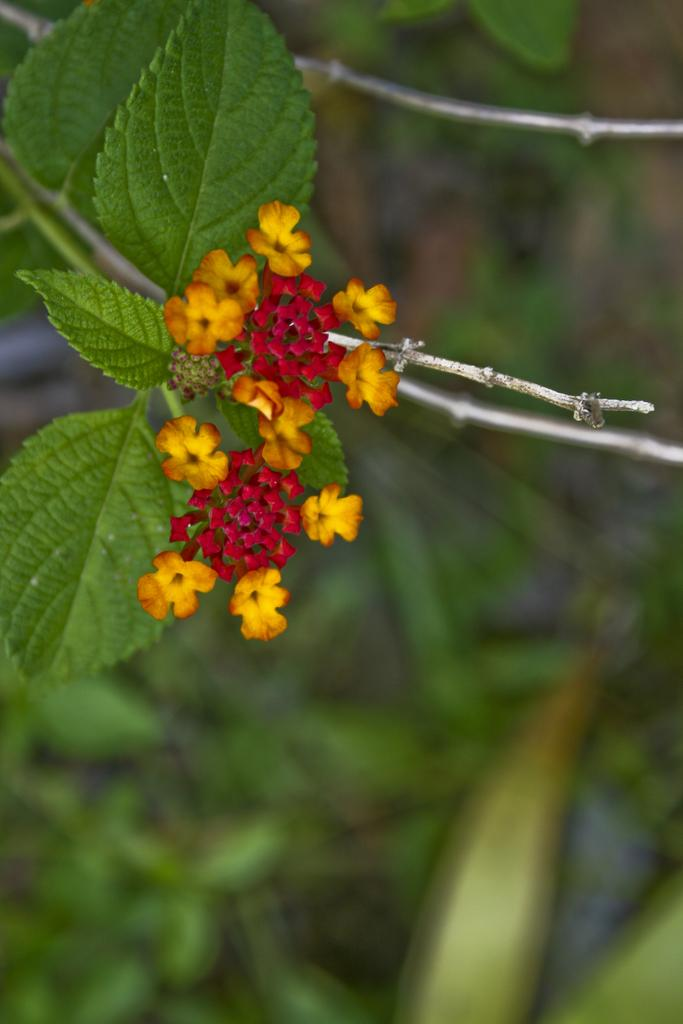What type of flora can be seen in the image? There are flowers in the image. What colors are the flowers? The flowers are red, yellow, and orange in color. Where are the flowers located? The flowers are on a plant. What color is the plant? The plant is green in color. Can you describe the background of the image? The background of the image is blurry. What else can be seen in the background? There are plants visible in the background. How many kittens are playing with the destruction of the boys in the image? There are no kittens, destruction, or boys present in the image; it features flowers on a plant with a blurry background. 